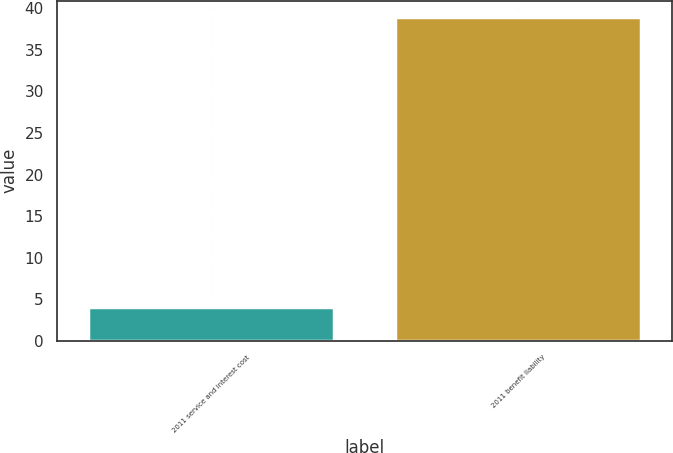Convert chart. <chart><loc_0><loc_0><loc_500><loc_500><bar_chart><fcel>2011 service and interest cost<fcel>2011 benefit liability<nl><fcel>4<fcel>39<nl></chart> 